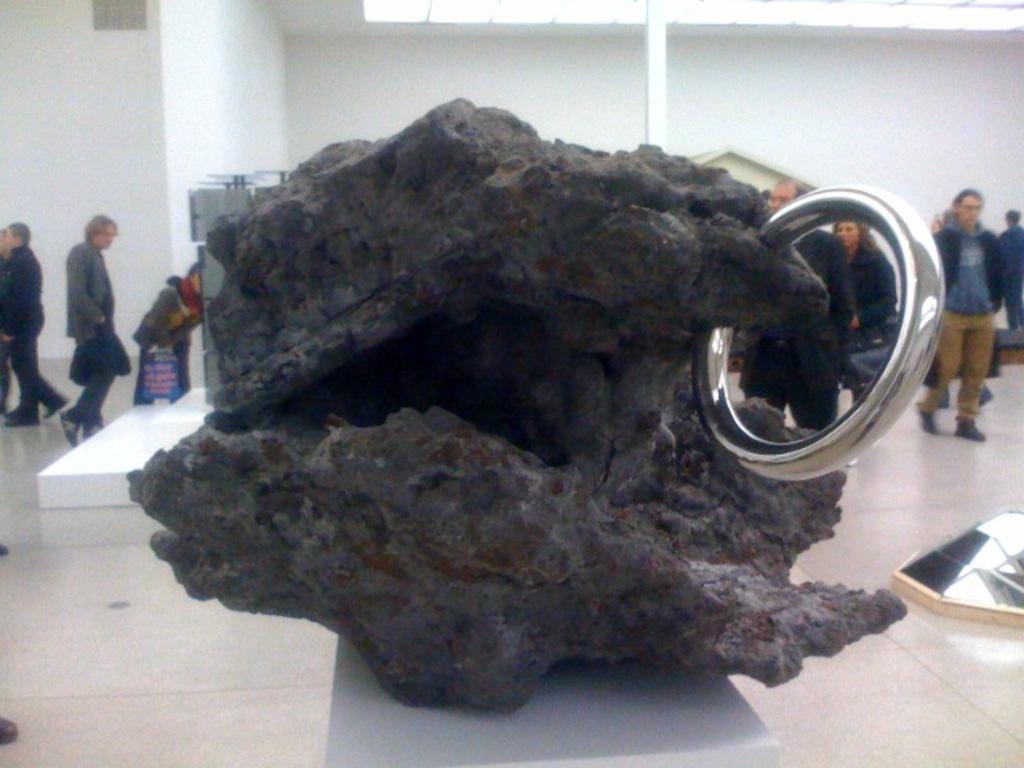In one or two sentences, can you explain what this image depicts? In the foreground there is a sculpture like object. In the middle of the picture we can see lot of people, pole, floor and white platform. In the background it is well. At the top we can see light and ceiling. 